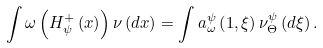Convert formula to latex. <formula><loc_0><loc_0><loc_500><loc_500>\int \omega \left ( H _ { \psi } ^ { + } \left ( x \right ) \right ) \nu \left ( d x \right ) = \int a _ { \omega } ^ { \psi } \left ( 1 , \xi \right ) \nu _ { \Theta } ^ { \psi } \left ( d \xi \right ) .</formula> 